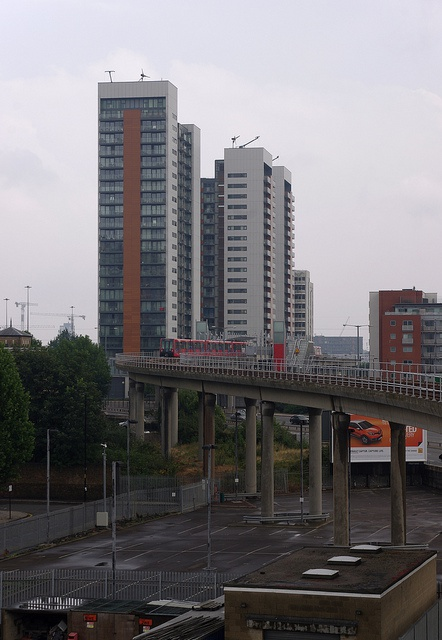Describe the objects in this image and their specific colors. I can see train in lavender, gray, black, maroon, and purple tones, bus in lavender, gray, black, maroon, and purple tones, car in lavender, black, and gray tones, and car in lavender, black, gray, and purple tones in this image. 